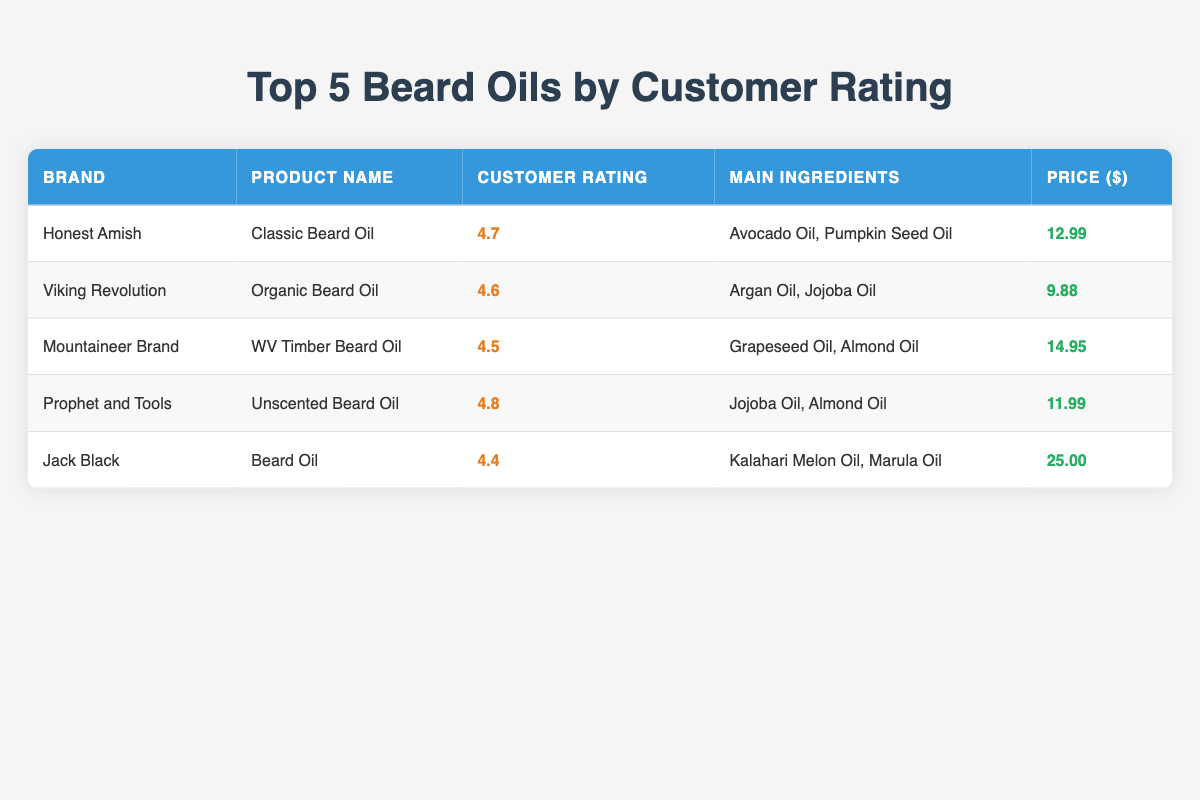What is the customer rating of the Honest Amish Classic Beard Oil? The table shows a specific entry for "Honest Amish Classic Beard Oil" under the "Customer Rating" column, where the value listed is 4.7.
Answer: 4.7 Which product has the highest customer rating? By inspecting the "Customer Rating" column, "Prophet and Tools Unscented Beard Oil" has the highest rating at 4.8 when compared to other products listed.
Answer: Prophet and Tools Unscented Beard Oil What are the main ingredients in Viking Revolution Organic Beard Oil? The table lists "Viking Revolution Organic Beard Oil" and shows its main ingredients are "Argan Oil, Jojoba Oil" in the corresponding row under the "Main Ingredients" column.
Answer: Argan Oil, Jojoba Oil What is the average customer rating of the beard oils listed? To calculate the average, add the ratings: 4.7 + 4.6 + 4.5 + 4.8 + 4.4 = 23.0. Then divide by the number of products, which is 5: 23.0 / 5 = 4.6.
Answer: 4.6 Is the price of Jack Black Beard Oil more than $20? Checking the "Price ($)" column, the price of "Jack Black Beard Oil" is $25.00, which is greater than $20.
Answer: Yes Which product has the lowest price? By comparing the prices listed in the "Price ($)" column, "Viking Revolution Organic Beard Oil" at $9.88 is the lowest price among the options given.
Answer: Viking Revolution Organic Beard Oil Are any of the beard oils unscented? The table indicates that "Prophet and Tools Unscented Beard Oil" is marked as "Unscented," affirming the presence of an unscented option in the products listed.
Answer: Yes What is the total price of all the beard oils combined? To find the total price, add all prices together: 12.99 + 9.88 + 14.95 + 11.99 + 25.00 = 74.81.
Answer: 74.81 Which two beard oils have similar customer ratings between 4.5 and 4.7? Considering the ratings, "Honest Amish Classic Beard Oil" (4.7) and "Viking Revolution Organic Beard Oil" (4.6) both fall within this range, making them the two products that fit the criteria.
Answer: Honest Amish Classic Beard Oil and Viking Revolution Organic Beard Oil 